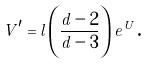Convert formula to latex. <formula><loc_0><loc_0><loc_500><loc_500>V ^ { \prime } = l \left ( \frac { d - 2 } { d - 3 } \right ) e ^ { U } \text {.}</formula> 